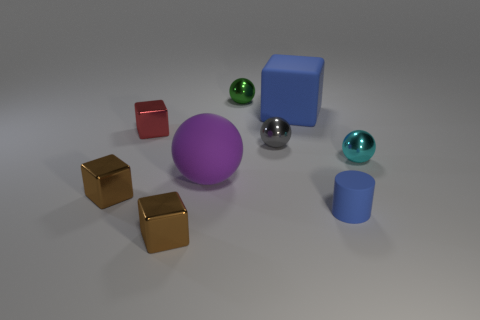If this were an image from a children's educational book, what might it be teaching? If this image were in a children's educational book, it might be included to teach various concepts. For example, it could be used to illustrate shapes by showing spheres, cubes, and cylinders. Additionally, it could demonstrate simple counting exercises or be part of a lesson on colors and color identification. The reflective surfaces of some objects might also be used to introduce concepts of light and reflection to the children. 